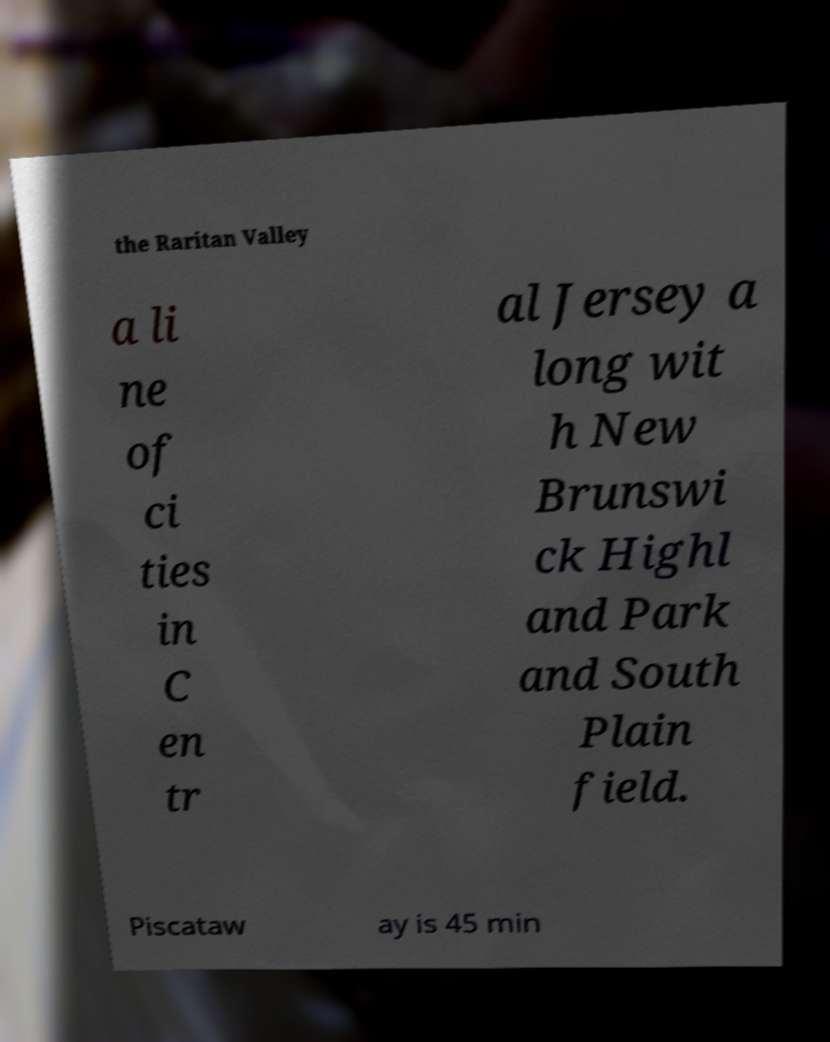I need the written content from this picture converted into text. Can you do that? the Raritan Valley a li ne of ci ties in C en tr al Jersey a long wit h New Brunswi ck Highl and Park and South Plain field. Piscataw ay is 45 min 